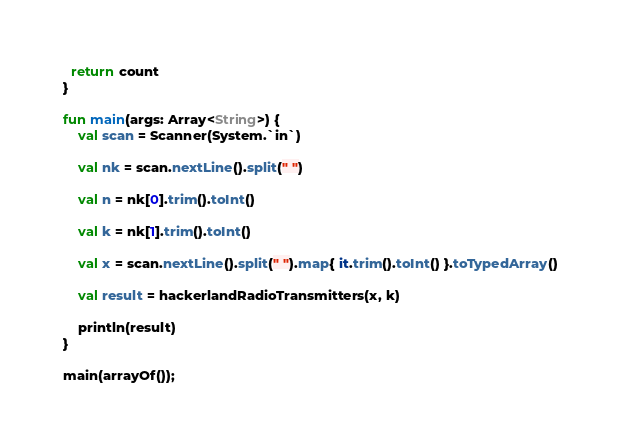Convert code to text. <code><loc_0><loc_0><loc_500><loc_500><_Kotlin_>
  return count
}

fun main(args: Array<String>) {
    val scan = Scanner(System.`in`)

    val nk = scan.nextLine().split(" ")

    val n = nk[0].trim().toInt()

    val k = nk[1].trim().toInt()

    val x = scan.nextLine().split(" ").map{ it.trim().toInt() }.toTypedArray()

    val result = hackerlandRadioTransmitters(x, k)

    println(result)
}

main(arrayOf());
</code> 